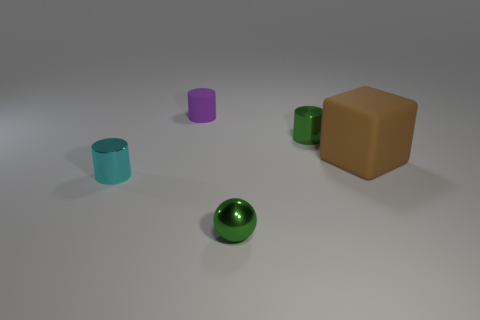The object that is the same color as the small sphere is what size?
Make the answer very short. Small. There is a green shiny object that is left of the tiny green metal object behind the rubber block; is there a cylinder that is to the right of it?
Provide a succinct answer. Yes. Is there any other thing that is made of the same material as the small purple cylinder?
Offer a very short reply. Yes. What number of small things are either cylinders or cyan metallic cylinders?
Your response must be concise. 3. There is a green metal thing that is in front of the large brown matte block; is its shape the same as the purple rubber object?
Your answer should be very brief. No. Is the number of yellow cylinders less than the number of small cyan cylinders?
Provide a succinct answer. Yes. Is there any other thing that has the same color as the small ball?
Provide a succinct answer. Yes. There is a metal object that is behind the tiny cyan cylinder; what shape is it?
Your answer should be compact. Cylinder. Does the tiny metallic sphere have the same color as the tiny metal cylinder to the right of the tiny purple cylinder?
Make the answer very short. Yes. Are there the same number of cylinders behind the brown thing and brown rubber blocks that are left of the purple rubber cylinder?
Your response must be concise. No. 